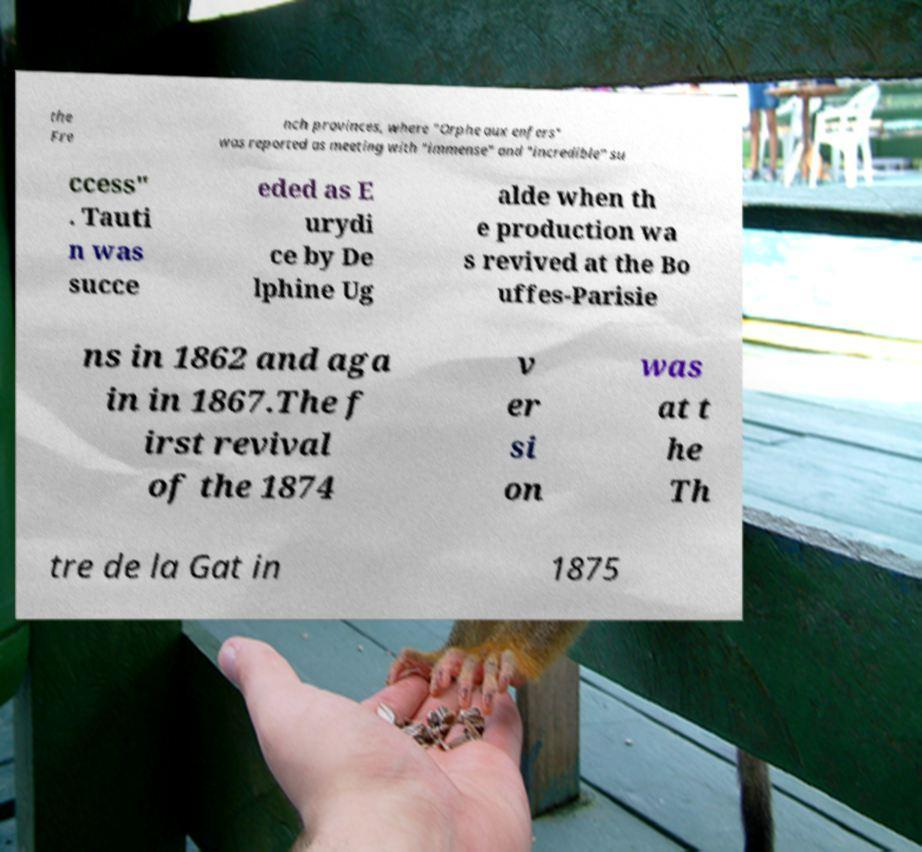For documentation purposes, I need the text within this image transcribed. Could you provide that? the Fre nch provinces, where "Orphe aux enfers" was reported as meeting with "immense" and "incredible" su ccess" . Tauti n was succe eded as E urydi ce by De lphine Ug alde when th e production wa s revived at the Bo uffes-Parisie ns in 1862 and aga in in 1867.The f irst revival of the 1874 v er si on was at t he Th tre de la Gat in 1875 